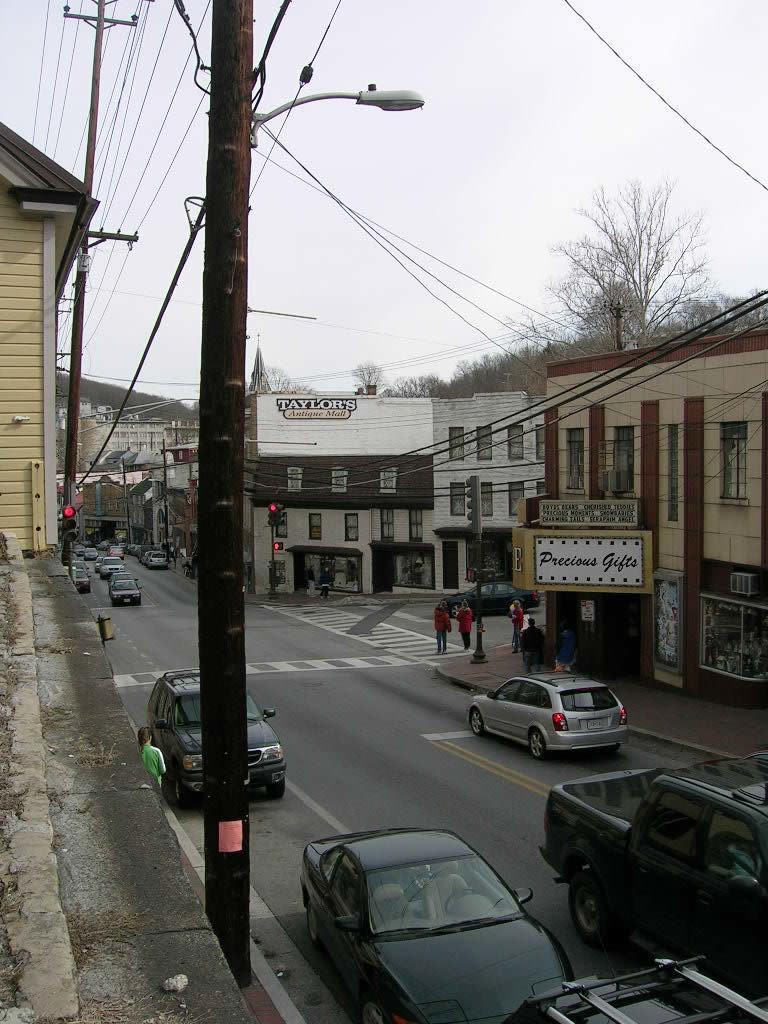Please provide a concise description of this image. In this picture there are poles in the image and there are cars on the road and there are buildings, trees, and posters in the background area of the image. 